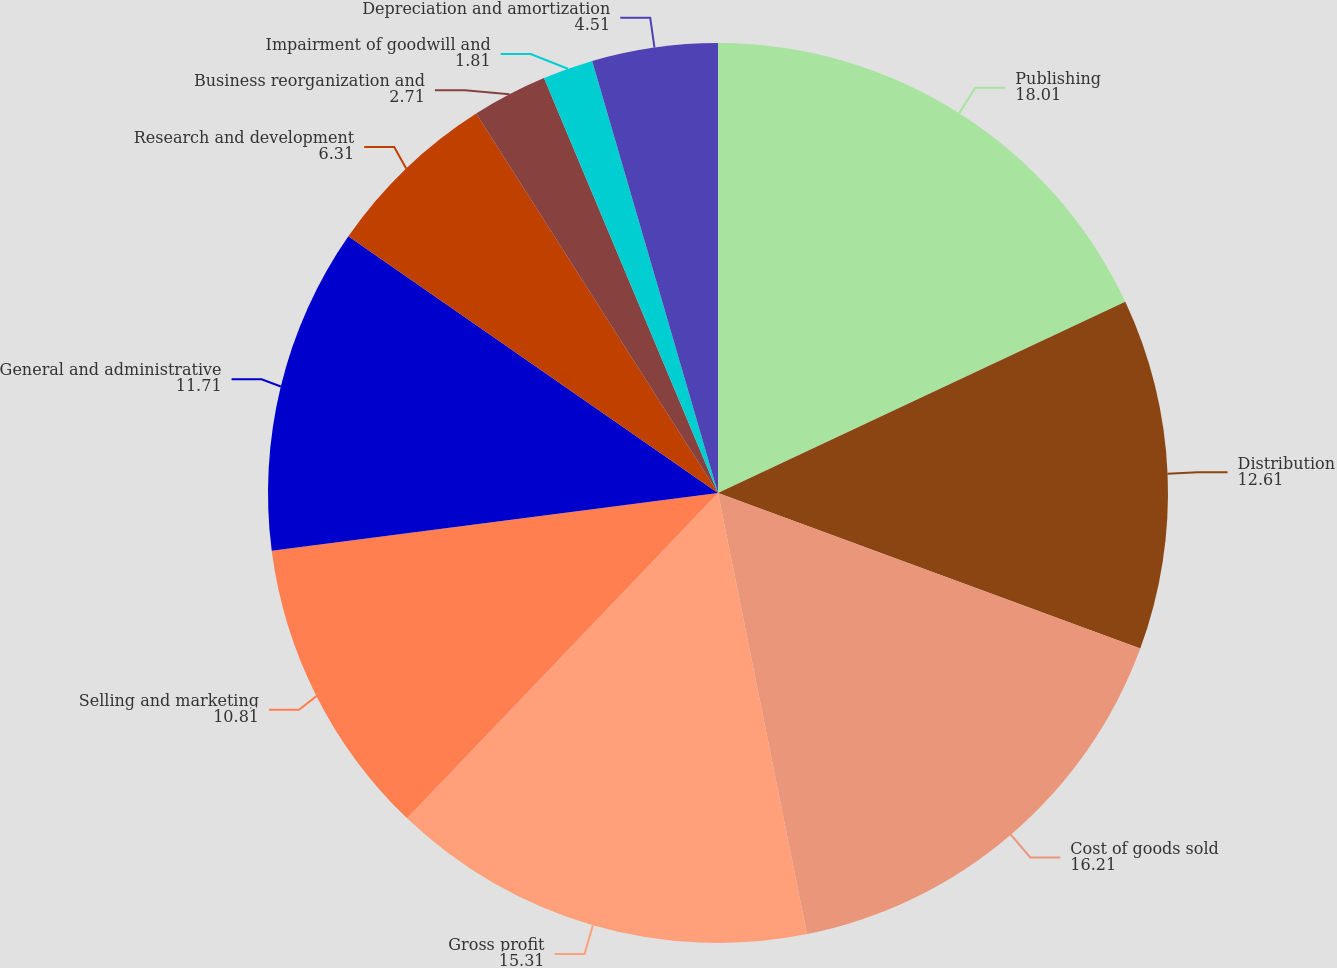<chart> <loc_0><loc_0><loc_500><loc_500><pie_chart><fcel>Publishing<fcel>Distribution<fcel>Cost of goods sold<fcel>Gross profit<fcel>Selling and marketing<fcel>General and administrative<fcel>Research and development<fcel>Business reorganization and<fcel>Impairment of goodwill and<fcel>Depreciation and amortization<nl><fcel>18.01%<fcel>12.61%<fcel>16.21%<fcel>15.31%<fcel>10.81%<fcel>11.71%<fcel>6.31%<fcel>2.71%<fcel>1.81%<fcel>4.51%<nl></chart> 